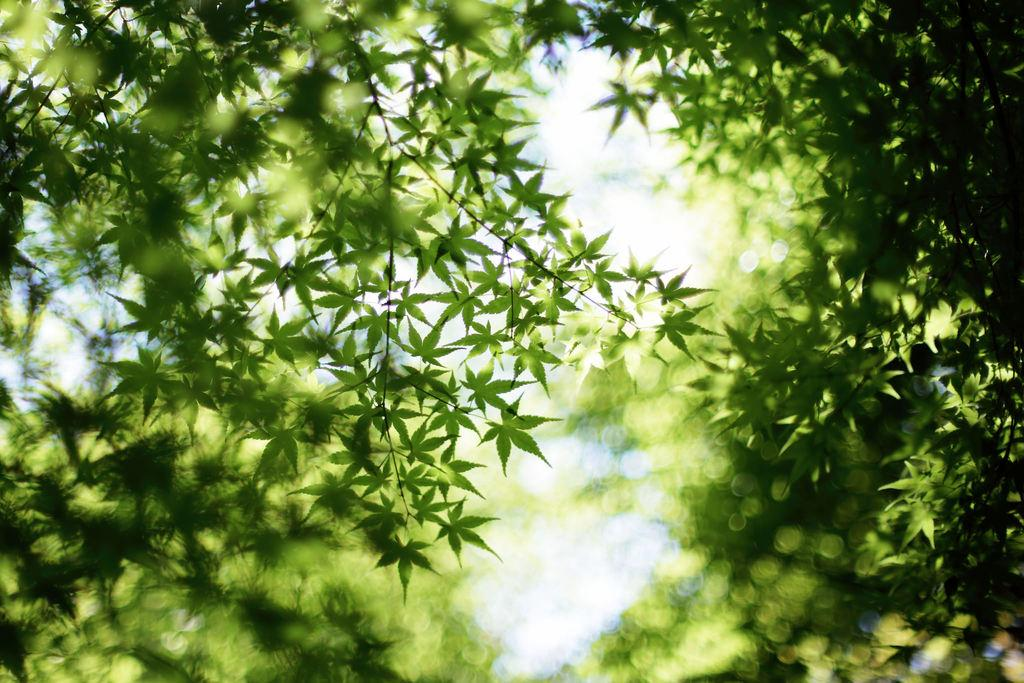What type of vegetation can be seen in the image? There are trees in the image. What is visible at the top of the image? The sky is visible at the top of the image. What arithmetic problem is being solved by the chickens in the image? There are no chickens present in the image, and therefore no arithmetic problem is being solved. What season is depicted in the image? The provided facts do not mention the season, so it cannot be determined from the image. 